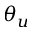<formula> <loc_0><loc_0><loc_500><loc_500>\theta _ { u }</formula> 